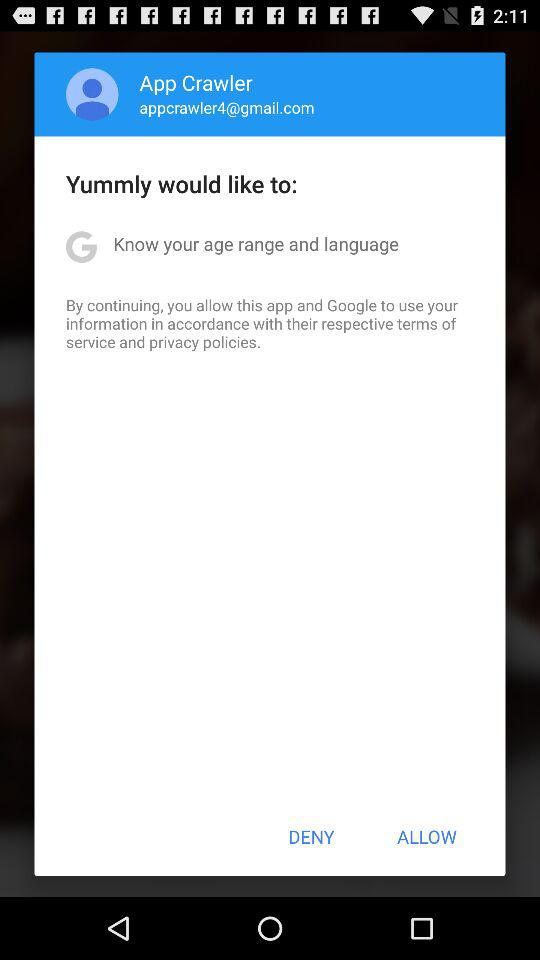What is the email address? The email address is appcrawler4@gmail.com. 